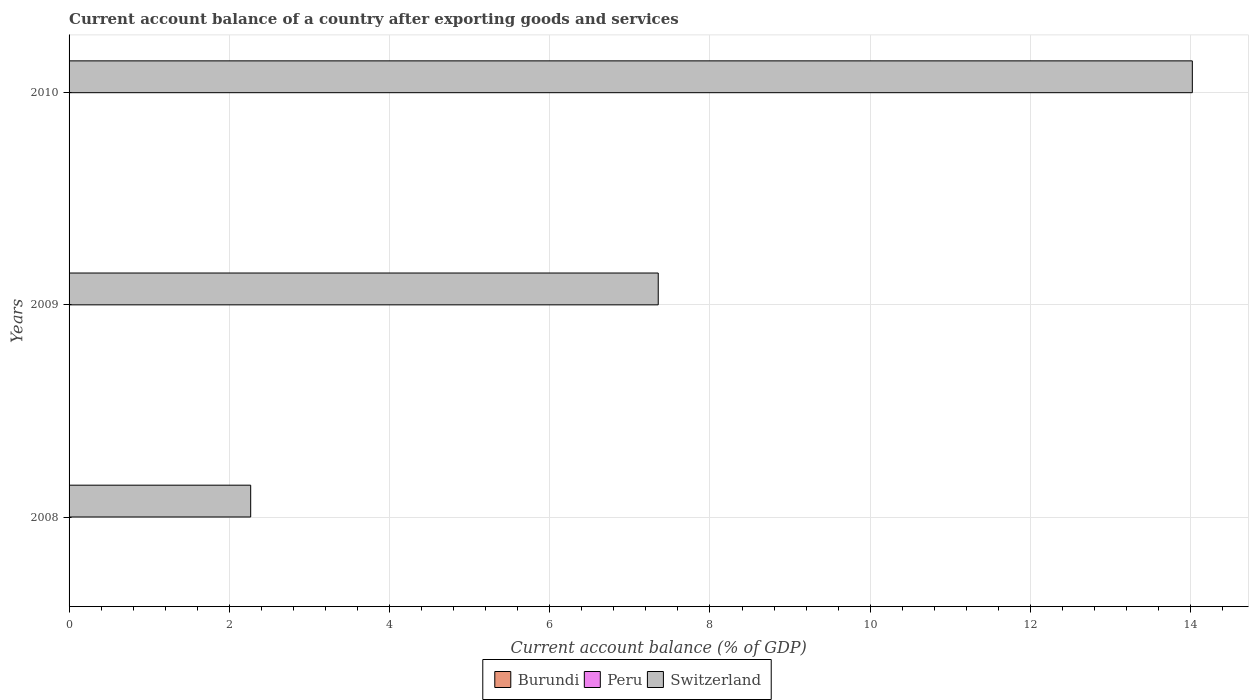How many different coloured bars are there?
Provide a succinct answer. 1. What is the label of the 3rd group of bars from the top?
Your response must be concise. 2008. In how many cases, is the number of bars for a given year not equal to the number of legend labels?
Make the answer very short. 3. Across all years, what is the maximum account balance in Switzerland?
Ensure brevity in your answer.  14.02. Across all years, what is the minimum account balance in Peru?
Offer a terse response. 0. What is the difference between the account balance in Switzerland in 2008 and that in 2009?
Make the answer very short. -5.09. What is the difference between the account balance in Burundi in 2010 and the account balance in Switzerland in 2008?
Ensure brevity in your answer.  -2.27. What is the average account balance in Burundi per year?
Keep it short and to the point. 0. What is the ratio of the account balance in Switzerland in 2008 to that in 2009?
Ensure brevity in your answer.  0.31. What is the difference between the highest and the second highest account balance in Switzerland?
Give a very brief answer. 6.67. What is the difference between the highest and the lowest account balance in Switzerland?
Provide a short and direct response. 11.75. In how many years, is the account balance in Switzerland greater than the average account balance in Switzerland taken over all years?
Your answer should be compact. 1. Is the sum of the account balance in Switzerland in 2008 and 2009 greater than the maximum account balance in Burundi across all years?
Offer a very short reply. Yes. Are all the bars in the graph horizontal?
Your answer should be compact. Yes. How many years are there in the graph?
Offer a terse response. 3. Does the graph contain any zero values?
Your response must be concise. Yes. Does the graph contain grids?
Offer a very short reply. Yes. Where does the legend appear in the graph?
Your response must be concise. Bottom center. How are the legend labels stacked?
Offer a very short reply. Horizontal. What is the title of the graph?
Offer a terse response. Current account balance of a country after exporting goods and services. What is the label or title of the X-axis?
Your answer should be compact. Current account balance (% of GDP). What is the label or title of the Y-axis?
Offer a very short reply. Years. What is the Current account balance (% of GDP) of Switzerland in 2008?
Your response must be concise. 2.27. What is the Current account balance (% of GDP) in Burundi in 2009?
Your answer should be very brief. 0. What is the Current account balance (% of GDP) of Switzerland in 2009?
Offer a terse response. 7.35. What is the Current account balance (% of GDP) of Burundi in 2010?
Make the answer very short. 0. What is the Current account balance (% of GDP) of Peru in 2010?
Keep it short and to the point. 0. What is the Current account balance (% of GDP) in Switzerland in 2010?
Offer a very short reply. 14.02. Across all years, what is the maximum Current account balance (% of GDP) of Switzerland?
Your answer should be compact. 14.02. Across all years, what is the minimum Current account balance (% of GDP) in Switzerland?
Your answer should be very brief. 2.27. What is the total Current account balance (% of GDP) of Peru in the graph?
Provide a short and direct response. 0. What is the total Current account balance (% of GDP) of Switzerland in the graph?
Keep it short and to the point. 23.64. What is the difference between the Current account balance (% of GDP) of Switzerland in 2008 and that in 2009?
Your answer should be very brief. -5.09. What is the difference between the Current account balance (% of GDP) in Switzerland in 2008 and that in 2010?
Offer a very short reply. -11.75. What is the difference between the Current account balance (% of GDP) of Switzerland in 2009 and that in 2010?
Give a very brief answer. -6.67. What is the average Current account balance (% of GDP) in Burundi per year?
Offer a very short reply. 0. What is the average Current account balance (% of GDP) in Switzerland per year?
Make the answer very short. 7.88. What is the ratio of the Current account balance (% of GDP) in Switzerland in 2008 to that in 2009?
Your answer should be very brief. 0.31. What is the ratio of the Current account balance (% of GDP) of Switzerland in 2008 to that in 2010?
Offer a terse response. 0.16. What is the ratio of the Current account balance (% of GDP) in Switzerland in 2009 to that in 2010?
Your answer should be compact. 0.52. What is the difference between the highest and the lowest Current account balance (% of GDP) of Switzerland?
Give a very brief answer. 11.75. 